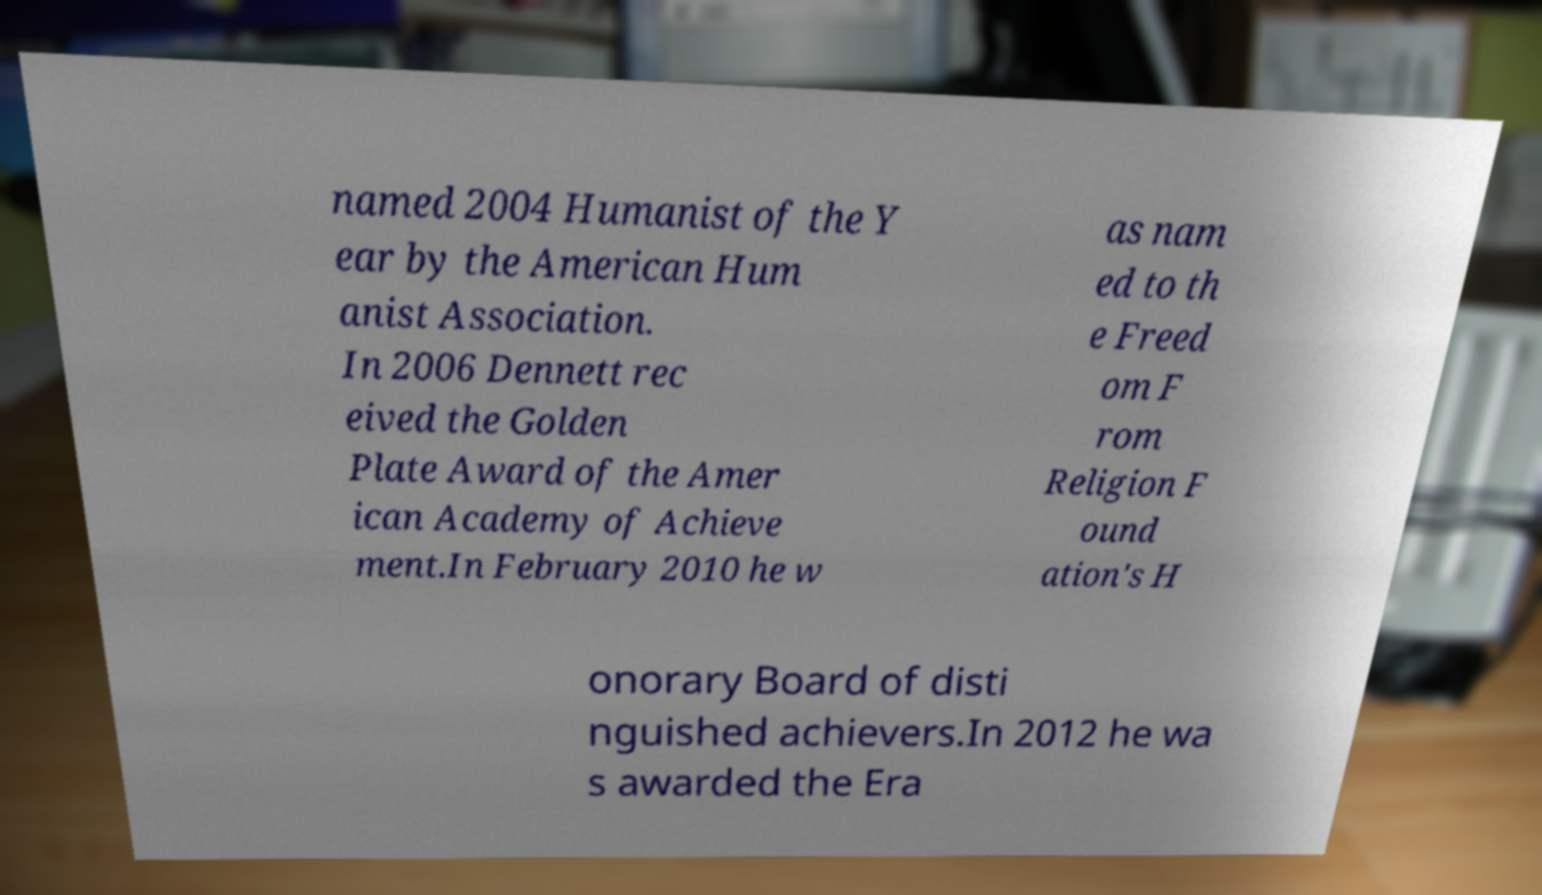I need the written content from this picture converted into text. Can you do that? named 2004 Humanist of the Y ear by the American Hum anist Association. In 2006 Dennett rec eived the Golden Plate Award of the Amer ican Academy of Achieve ment.In February 2010 he w as nam ed to th e Freed om F rom Religion F ound ation's H onorary Board of disti nguished achievers.In 2012 he wa s awarded the Era 